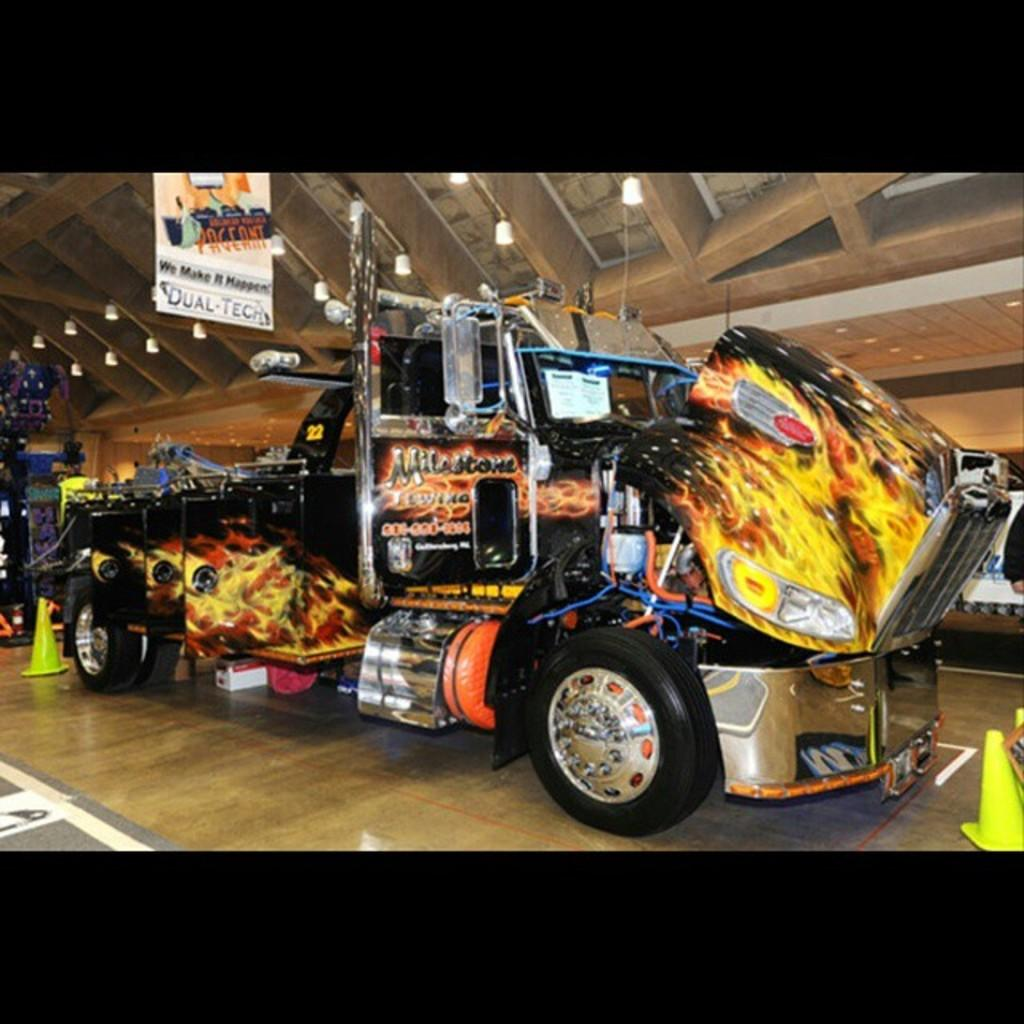What type of vehicle is in the image? There is a monster truck in the image. Where is the monster truck located? The monster truck is inside a hall. What can be seen on the ceiling in the image? There are lights on the ceiling in the image. What type of drain is visible in the image? There is no drain present in the image; it features a monster truck inside a hall with lights on the ceiling. 